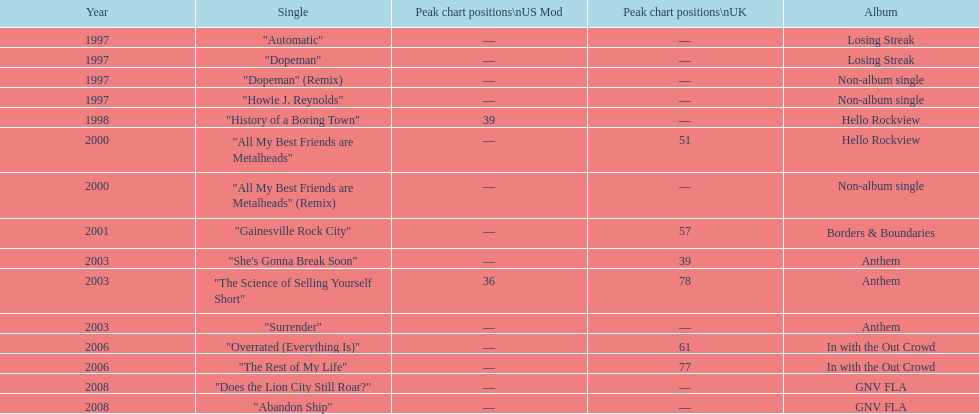Apart from "dopeman," what is one other single featured on the losing streak album? "Automatic". Could you help me parse every detail presented in this table? {'header': ['Year', 'Single', 'Peak chart positions\\nUS Mod', 'Peak chart positions\\nUK', 'Album'], 'rows': [['1997', '"Automatic"', '—', '—', 'Losing Streak'], ['1997', '"Dopeman"', '—', '—', 'Losing Streak'], ['1997', '"Dopeman" (Remix)', '—', '—', 'Non-album single'], ['1997', '"Howie J. Reynolds"', '—', '—', 'Non-album single'], ['1998', '"History of a Boring Town"', '39', '—', 'Hello Rockview'], ['2000', '"All My Best Friends are Metalheads"', '—', '51', 'Hello Rockview'], ['2000', '"All My Best Friends are Metalheads" (Remix)', '—', '—', 'Non-album single'], ['2001', '"Gainesville Rock City"', '—', '57', 'Borders & Boundaries'], ['2003', '"She\'s Gonna Break Soon"', '—', '39', 'Anthem'], ['2003', '"The Science of Selling Yourself Short"', '36', '78', 'Anthem'], ['2003', '"Surrender"', '—', '—', 'Anthem'], ['2006', '"Overrated (Everything Is)"', '—', '61', 'In with the Out Crowd'], ['2006', '"The Rest of My Life"', '—', '77', 'In with the Out Crowd'], ['2008', '"Does the Lion City Still Roar?"', '—', '—', 'GNV FLA'], ['2008', '"Abandon Ship"', '—', '—', 'GNV FLA']]} 